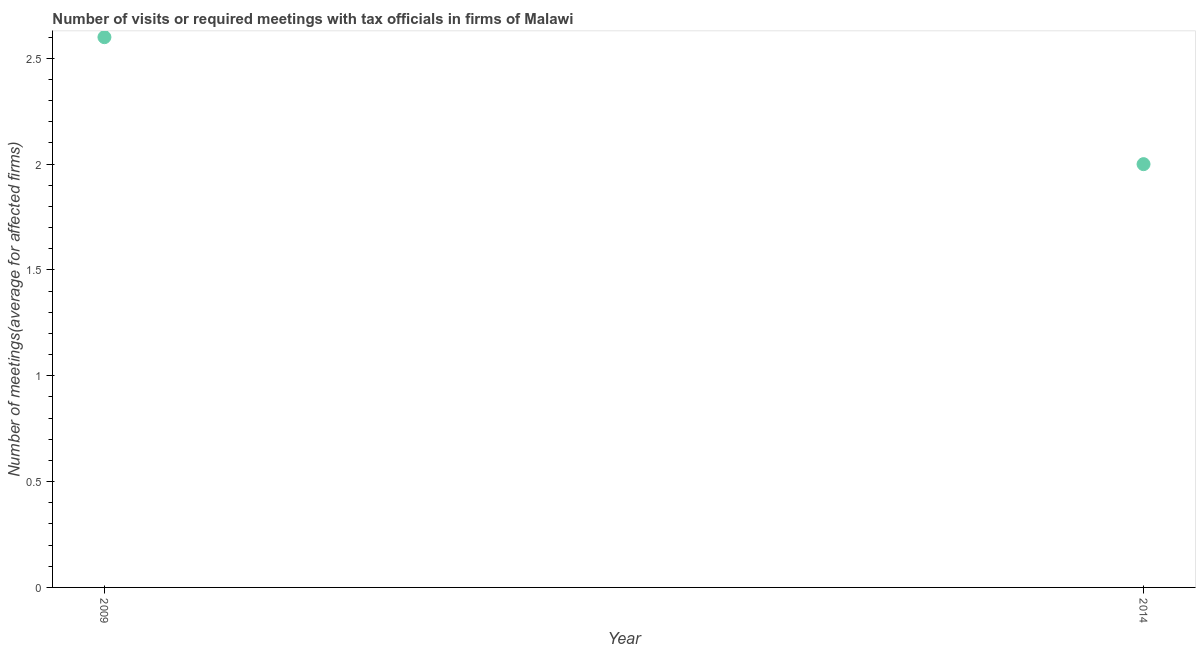What is the number of required meetings with tax officials in 2009?
Your answer should be very brief. 2.6. In which year was the number of required meetings with tax officials maximum?
Keep it short and to the point. 2009. What is the sum of the number of required meetings with tax officials?
Offer a very short reply. 4.6. What is the difference between the number of required meetings with tax officials in 2009 and 2014?
Offer a very short reply. 0.6. What is the median number of required meetings with tax officials?
Offer a very short reply. 2.3. In how many years, is the number of required meetings with tax officials greater than 1.9 ?
Make the answer very short. 2. Does the number of required meetings with tax officials monotonically increase over the years?
Keep it short and to the point. No. How many dotlines are there?
Provide a short and direct response. 1. How many years are there in the graph?
Your response must be concise. 2. Are the values on the major ticks of Y-axis written in scientific E-notation?
Provide a succinct answer. No. What is the title of the graph?
Provide a succinct answer. Number of visits or required meetings with tax officials in firms of Malawi. What is the label or title of the Y-axis?
Your answer should be very brief. Number of meetings(average for affected firms). What is the Number of meetings(average for affected firms) in 2009?
Provide a succinct answer. 2.6. 